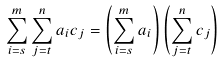<formula> <loc_0><loc_0><loc_500><loc_500>\sum _ { i = s } ^ { m } \sum _ { j = t } ^ { n } { a _ { i } } { c _ { j } } = \left ( \sum _ { i = s } ^ { m } a _ { i } \right ) \left ( \sum _ { j = t } ^ { n } c _ { j } \right )</formula> 